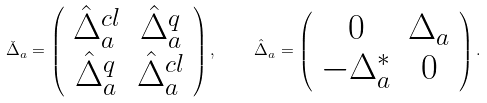<formula> <loc_0><loc_0><loc_500><loc_500>\check { \Delta } _ { a } = \left ( \begin{array} { c c } \hat { \Delta } ^ { c l } _ { a } & \hat { \Delta } ^ { q } _ { a } \\ \hat { \Delta } ^ { q } _ { a } & \hat { \Delta } ^ { c l } _ { a } \end{array} \right ) , \quad \hat { \Delta } _ { a } = \left ( \begin{array} { c c } 0 & \Delta _ { a } \\ - \Delta ^ { * } _ { a } & 0 \end{array} \right ) .</formula> 